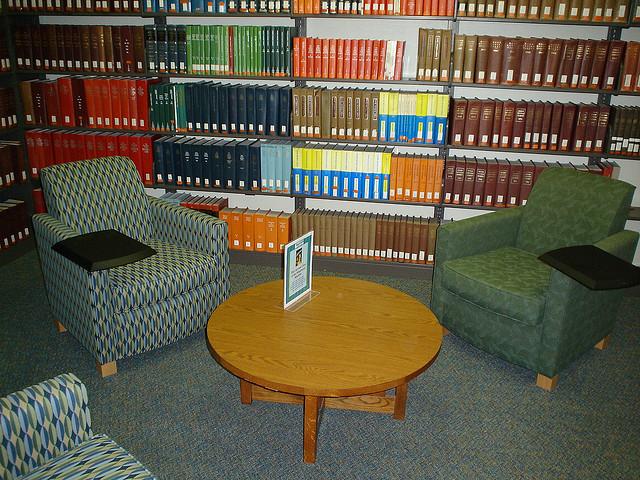What are the black pieces of the furniture?
Answer briefly. Trays. What room is this?
Answer briefly. Library. What is the title on one of these book?
Concise answer only. Encyclopedia. 